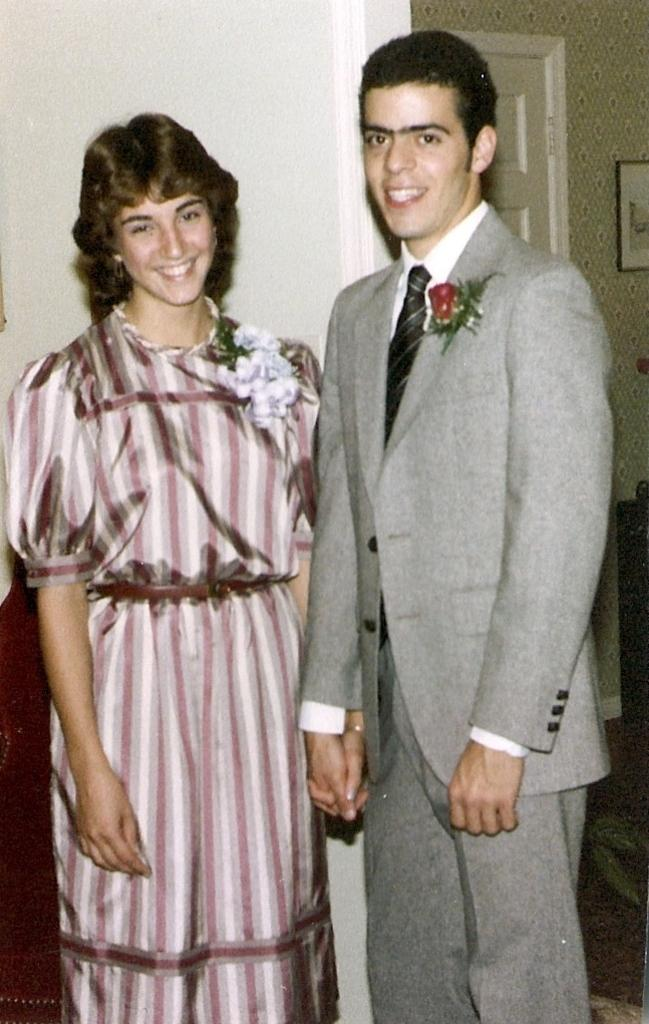What can be seen in the background of the image? There is a wall, a frame, and what appears to be a door in the background of the image. Who is present in the image? There is a man and a woman in the image. What are the expressions of the man and woman in the image? Both the man and the woman are smiling in the image. How many ants are crawling on the man's shoulder in the image? There are no ants present in the image. What type of spark can be seen coming from the woman's hand in the image? There is no spark present in the image. 